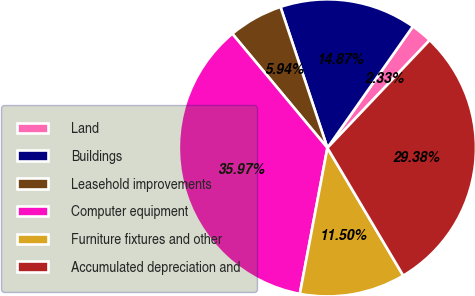Convert chart. <chart><loc_0><loc_0><loc_500><loc_500><pie_chart><fcel>Land<fcel>Buildings<fcel>Leasehold improvements<fcel>Computer equipment<fcel>Furniture fixtures and other<fcel>Accumulated depreciation and<nl><fcel>2.33%<fcel>14.87%<fcel>5.94%<fcel>35.97%<fcel>11.5%<fcel>29.38%<nl></chart> 